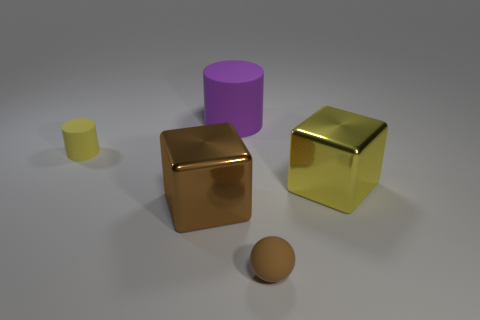There is a block that is the same color as the matte ball; what is its material?
Ensure brevity in your answer.  Metal. Is the big brown thing made of the same material as the tiny thing left of the purple matte object?
Offer a very short reply. No. What number of things are cylinders or tiny spheres?
Your answer should be very brief. 3. There is a metal object that is to the left of the big purple thing; is it the same size as the rubber cylinder right of the yellow cylinder?
Offer a terse response. Yes. How many cylinders are either rubber things or small gray things?
Make the answer very short. 2. Are there any tiny yellow things?
Give a very brief answer. Yes. Is there any other thing that is the same shape as the small yellow rubber object?
Ensure brevity in your answer.  Yes. Is the color of the large rubber thing the same as the matte ball?
Keep it short and to the point. No. What number of objects are yellow things that are right of the brown ball or large brown things?
Offer a terse response. 2. There is a matte object on the left side of the cylinder behind the yellow matte object; what number of brown objects are to the left of it?
Offer a very short reply. 0. 